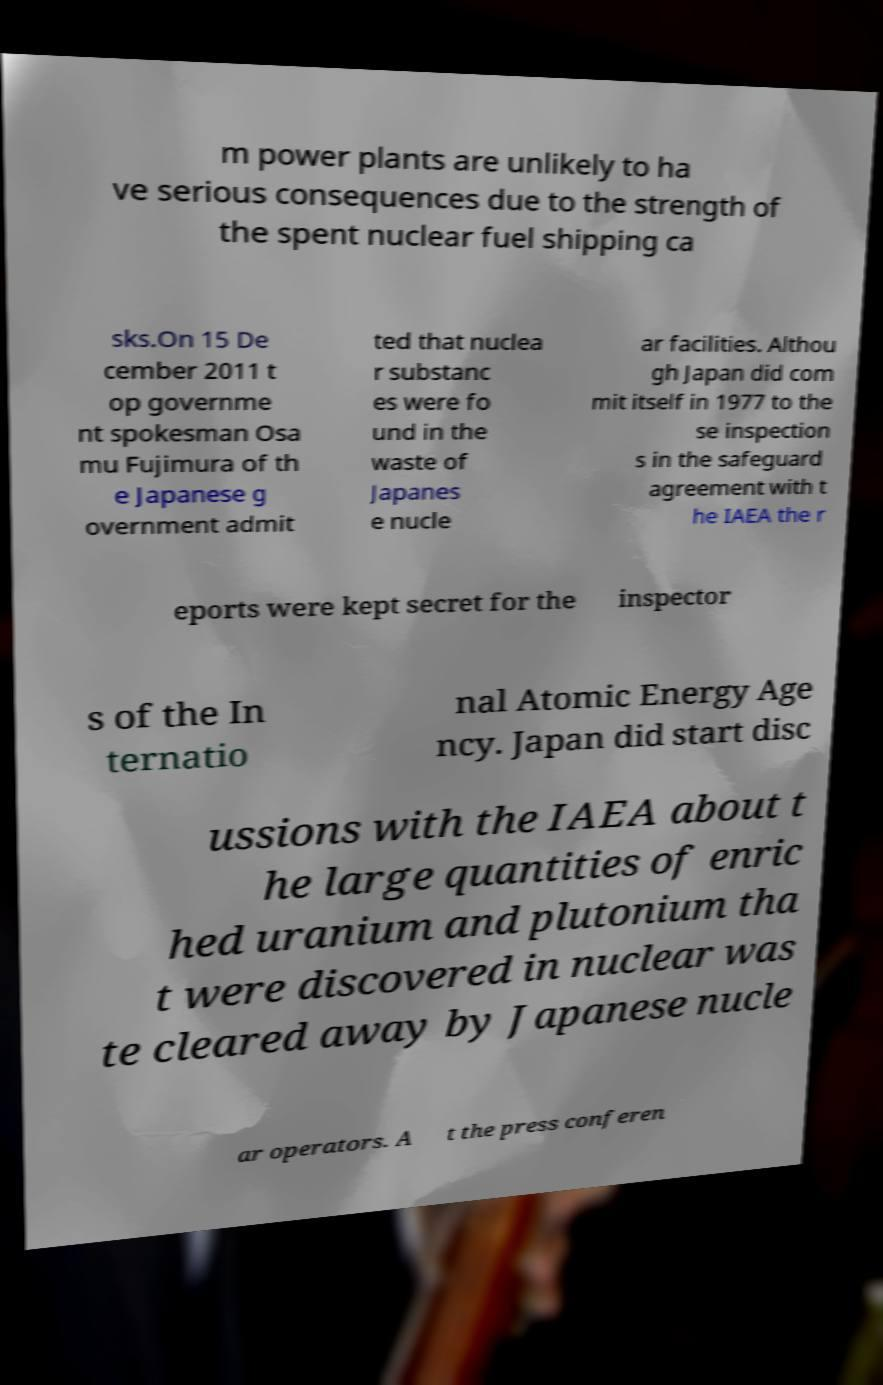Can you accurately transcribe the text from the provided image for me? m power plants are unlikely to ha ve serious consequences due to the strength of the spent nuclear fuel shipping ca sks.On 15 De cember 2011 t op governme nt spokesman Osa mu Fujimura of th e Japanese g overnment admit ted that nuclea r substanc es were fo und in the waste of Japanes e nucle ar facilities. Althou gh Japan did com mit itself in 1977 to the se inspection s in the safeguard agreement with t he IAEA the r eports were kept secret for the inspector s of the In ternatio nal Atomic Energy Age ncy. Japan did start disc ussions with the IAEA about t he large quantities of enric hed uranium and plutonium tha t were discovered in nuclear was te cleared away by Japanese nucle ar operators. A t the press conferen 